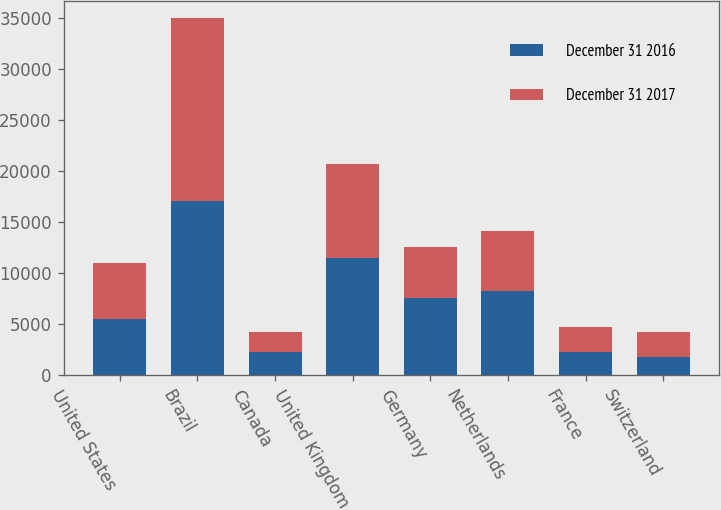Convert chart to OTSL. <chart><loc_0><loc_0><loc_500><loc_500><stacked_bar_chart><ecel><fcel>United States<fcel>Brazil<fcel>Canada<fcel>United Kingdom<fcel>Germany<fcel>Netherlands<fcel>France<fcel>Switzerland<nl><fcel>December 31 2016<fcel>5494<fcel>17030<fcel>2238<fcel>11528<fcel>7522<fcel>8225<fcel>2305<fcel>1755<nl><fcel>December 31 2017<fcel>5494<fcel>17910<fcel>1977<fcel>9127<fcel>5040<fcel>5948<fcel>2428<fcel>2450<nl></chart> 